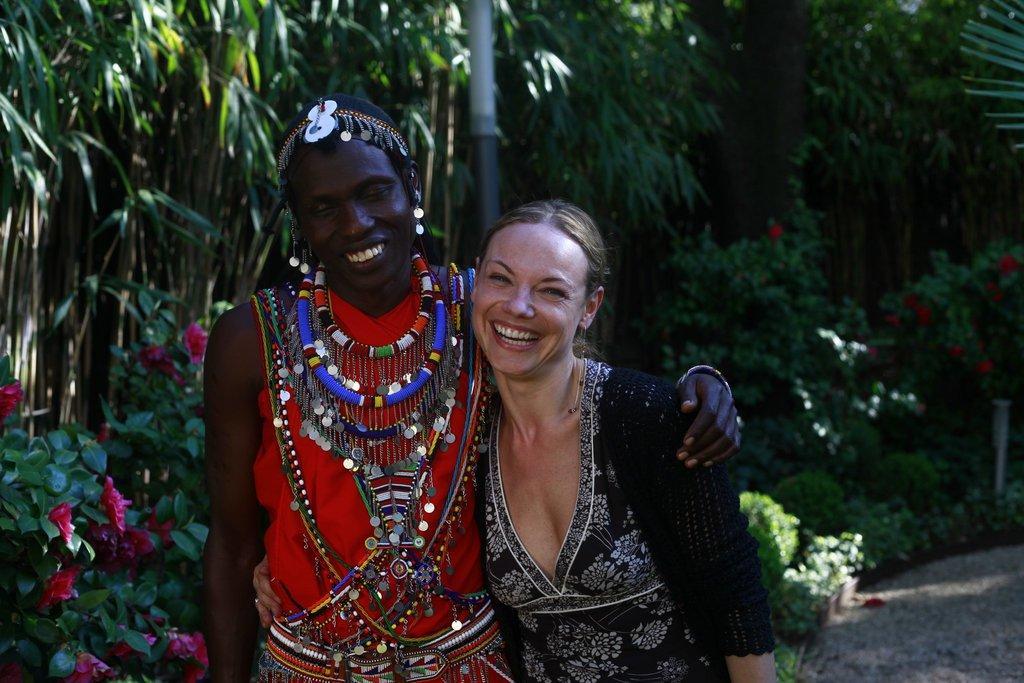Describe this image in one or two sentences. In this image I can see two people with black, white and red color dresses. In the background I can see the plants and trees. I can see some red color flowers to the plants. 